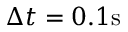<formula> <loc_0><loc_0><loc_500><loc_500>\Delta t = 0 . 1 s</formula> 